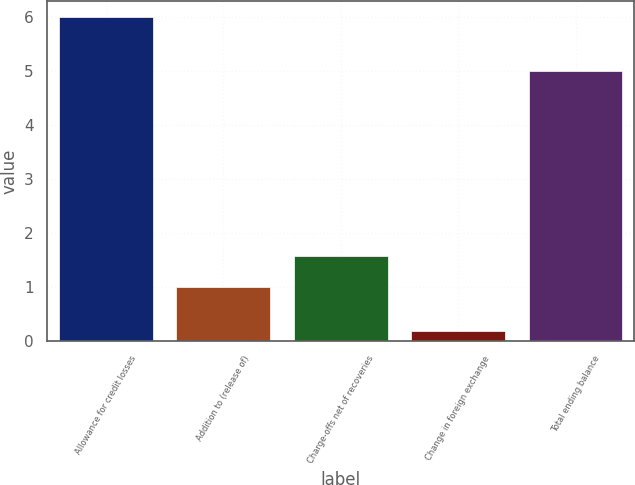Convert chart. <chart><loc_0><loc_0><loc_500><loc_500><bar_chart><fcel>Allowance for credit losses<fcel>Addition to (release of)<fcel>Charge-offs net of recoveries<fcel>Change in foreign exchange<fcel>Total ending balance<nl><fcel>6<fcel>1<fcel>1.58<fcel>0.19<fcel>5<nl></chart> 